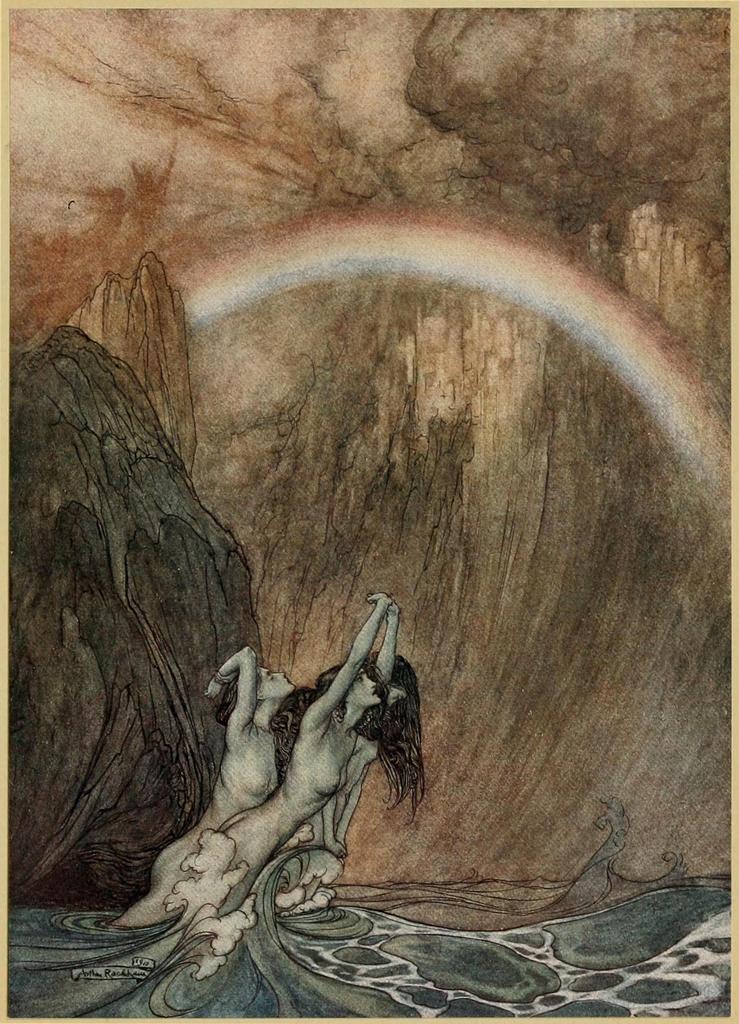Could you give a brief overview of what you see in this image? This is a painting. In this painting, we can see there are three woman in nude and they are partially in the water. In the background, there is a rainbow, there are mountains and there are clouds in the sky. 